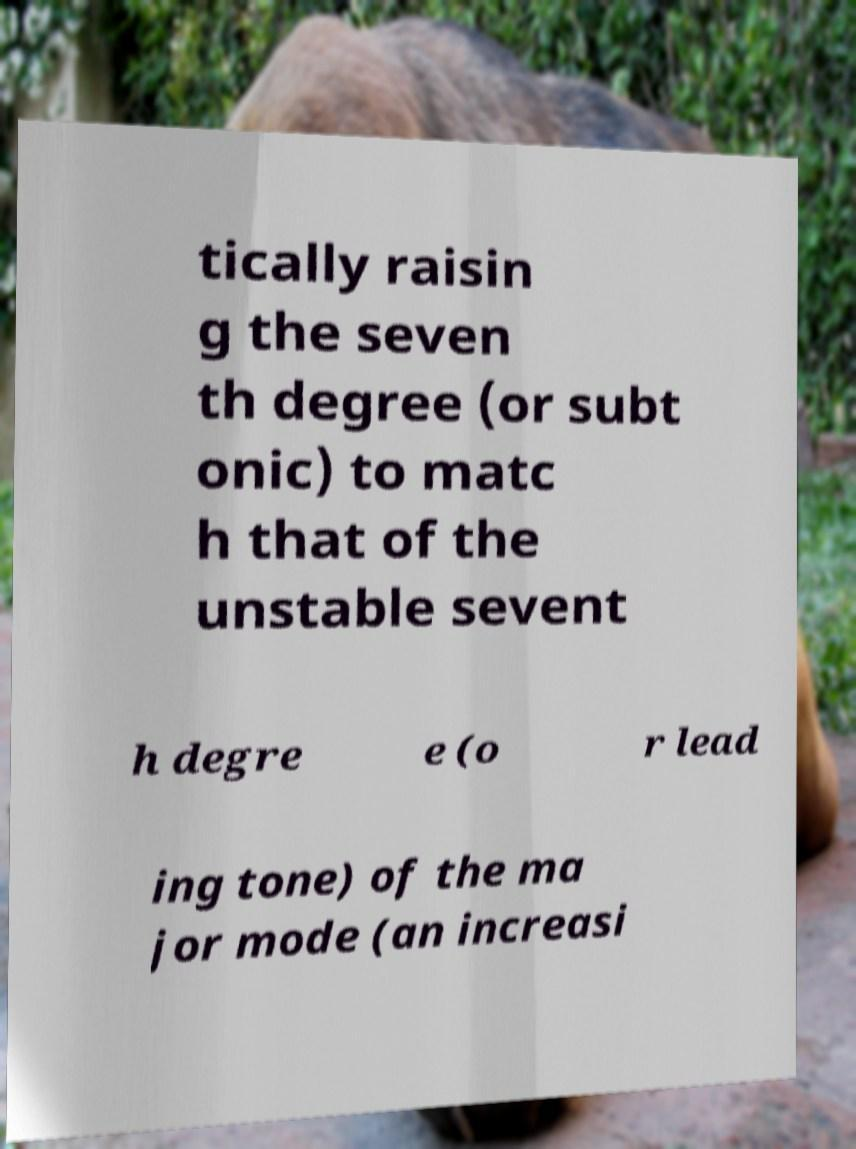For documentation purposes, I need the text within this image transcribed. Could you provide that? tically raisin g the seven th degree (or subt onic) to matc h that of the unstable sevent h degre e (o r lead ing tone) of the ma jor mode (an increasi 